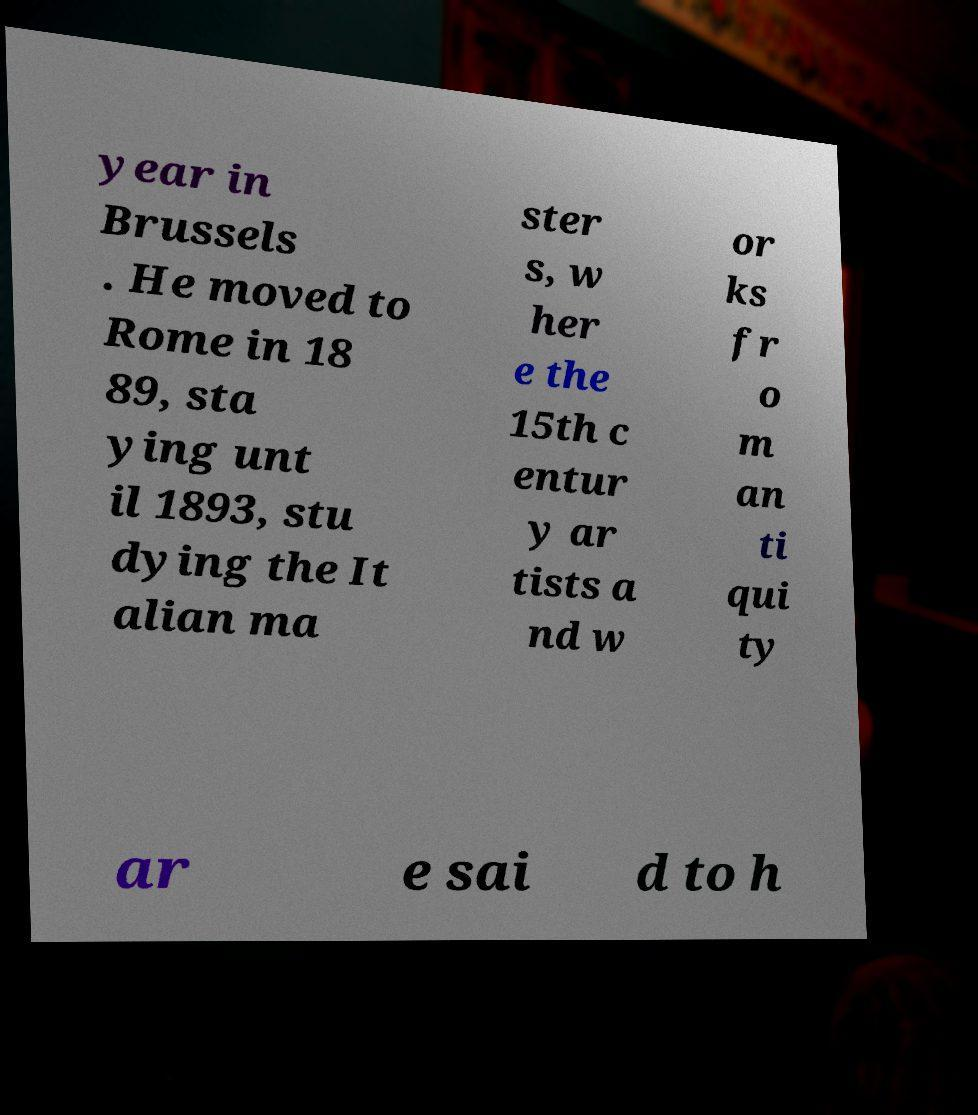Could you extract and type out the text from this image? year in Brussels . He moved to Rome in 18 89, sta ying unt il 1893, stu dying the It alian ma ster s, w her e the 15th c entur y ar tists a nd w or ks fr o m an ti qui ty ar e sai d to h 